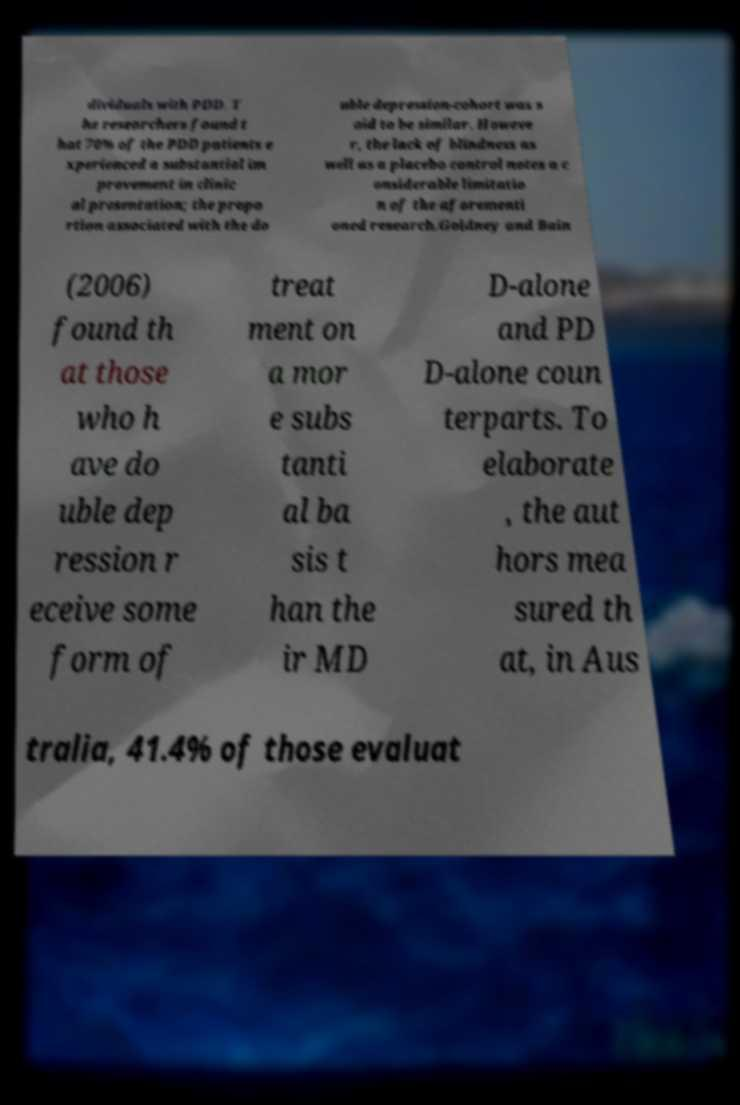For documentation purposes, I need the text within this image transcribed. Could you provide that? dividuals with PDD. T he researchers found t hat 70% of the PDD patients e xperienced a substantial im provement in clinic al presentation; the propo rtion associated with the do uble depression-cohort was s aid to be similar. Howeve r, the lack of blindness as well as a placebo control notes a c onsiderable limitatio n of the aforementi oned research.Goldney and Bain (2006) found th at those who h ave do uble dep ression r eceive some form of treat ment on a mor e subs tanti al ba sis t han the ir MD D-alone and PD D-alone coun terparts. To elaborate , the aut hors mea sured th at, in Aus tralia, 41.4% of those evaluat 